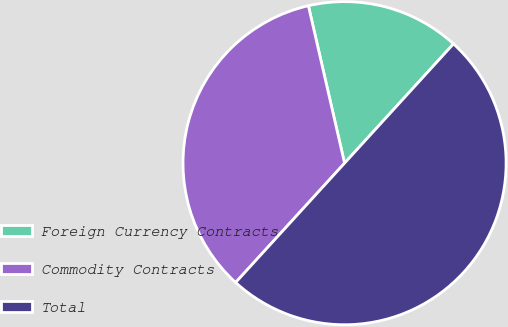Convert chart to OTSL. <chart><loc_0><loc_0><loc_500><loc_500><pie_chart><fcel>Foreign Currency Contracts<fcel>Commodity Contracts<fcel>Total<nl><fcel>15.37%<fcel>34.63%<fcel>50.0%<nl></chart> 